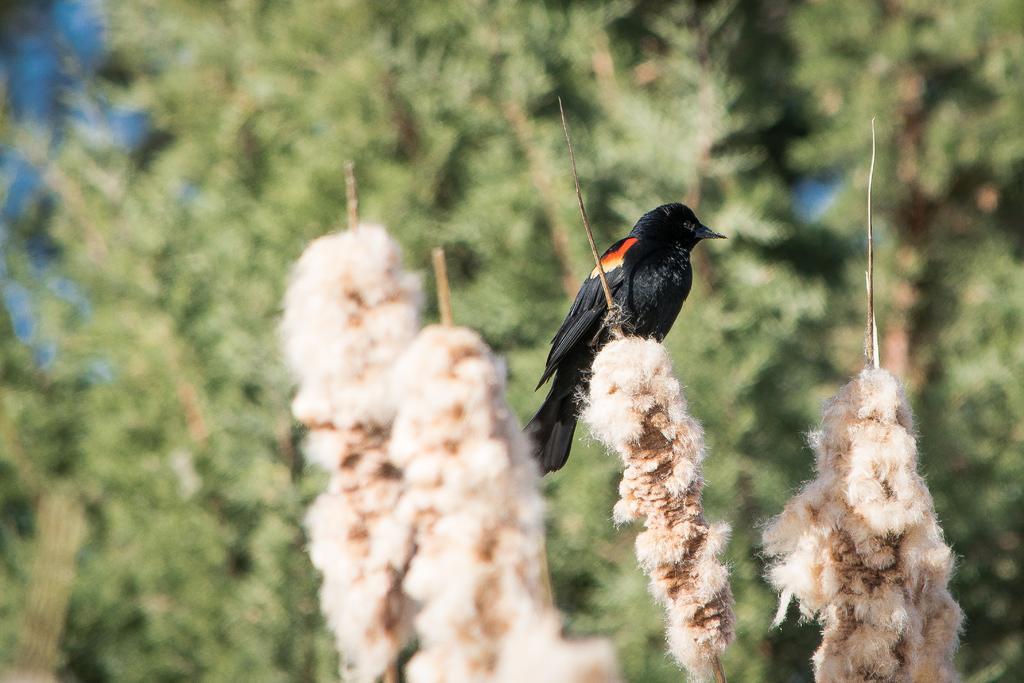Can you describe this image briefly? Here we can see a bird. There is a blur background with greenery. 